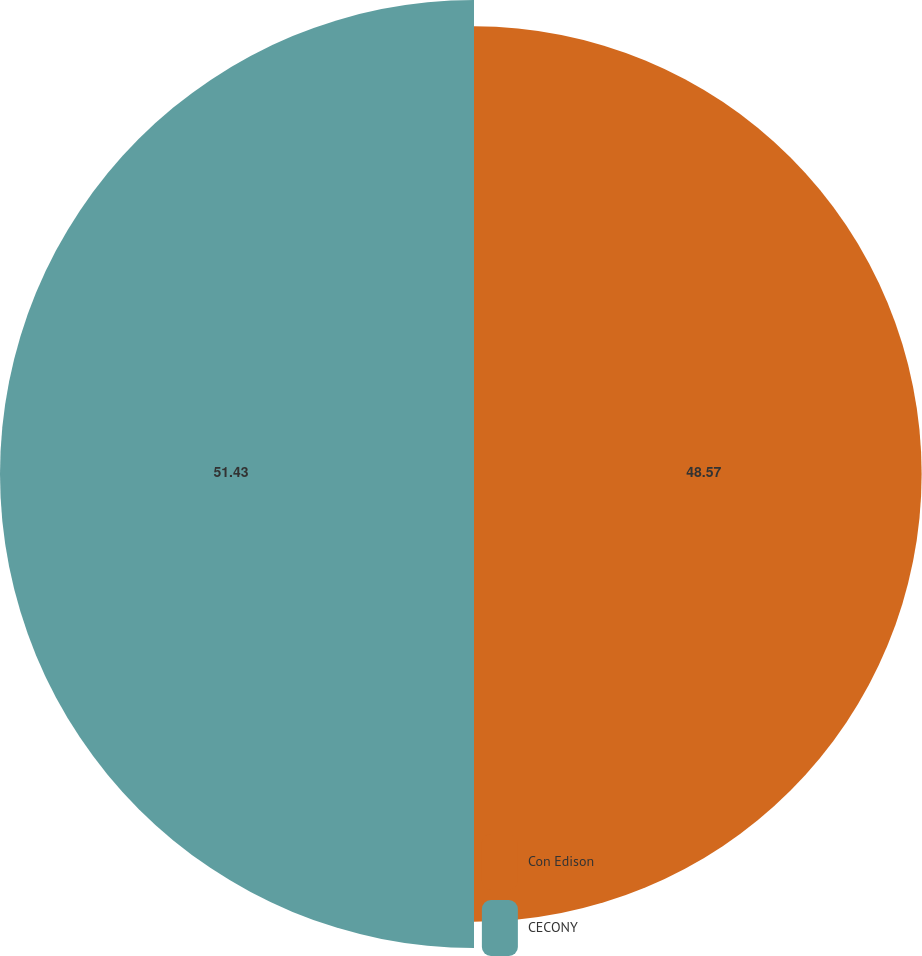<chart> <loc_0><loc_0><loc_500><loc_500><pie_chart><fcel>Con Edison<fcel>CECONY<nl><fcel>48.57%<fcel>51.43%<nl></chart> 